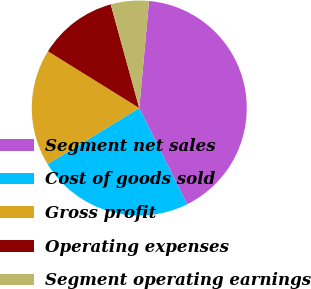Convert chart. <chart><loc_0><loc_0><loc_500><loc_500><pie_chart><fcel>Segment net sales<fcel>Cost of goods sold<fcel>Gross profit<fcel>Operating expenses<fcel>Segment operating earnings<nl><fcel>41.2%<fcel>23.61%<fcel>17.59%<fcel>11.87%<fcel>5.73%<nl></chart> 